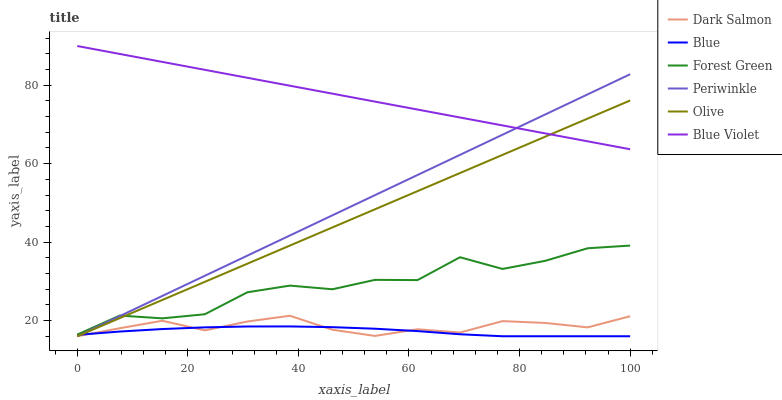Does Blue have the minimum area under the curve?
Answer yes or no. Yes. Does Blue Violet have the maximum area under the curve?
Answer yes or no. Yes. Does Dark Salmon have the minimum area under the curve?
Answer yes or no. No. Does Dark Salmon have the maximum area under the curve?
Answer yes or no. No. Is Olive the smoothest?
Answer yes or no. Yes. Is Forest Green the roughest?
Answer yes or no. Yes. Is Dark Salmon the smoothest?
Answer yes or no. No. Is Dark Salmon the roughest?
Answer yes or no. No. Does Blue have the lowest value?
Answer yes or no. Yes. Does Forest Green have the lowest value?
Answer yes or no. No. Does Blue Violet have the highest value?
Answer yes or no. Yes. Does Dark Salmon have the highest value?
Answer yes or no. No. Is Forest Green less than Blue Violet?
Answer yes or no. Yes. Is Blue Violet greater than Blue?
Answer yes or no. Yes. Does Dark Salmon intersect Olive?
Answer yes or no. Yes. Is Dark Salmon less than Olive?
Answer yes or no. No. Is Dark Salmon greater than Olive?
Answer yes or no. No. Does Forest Green intersect Blue Violet?
Answer yes or no. No. 